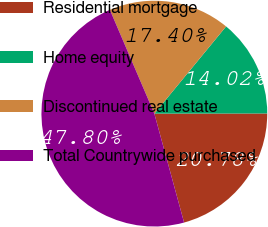<chart> <loc_0><loc_0><loc_500><loc_500><pie_chart><fcel>Residential mortgage<fcel>Home equity<fcel>Discontinued real estate<fcel>Total Countrywide purchased<nl><fcel>20.78%<fcel>14.02%<fcel>17.4%<fcel>47.8%<nl></chart> 